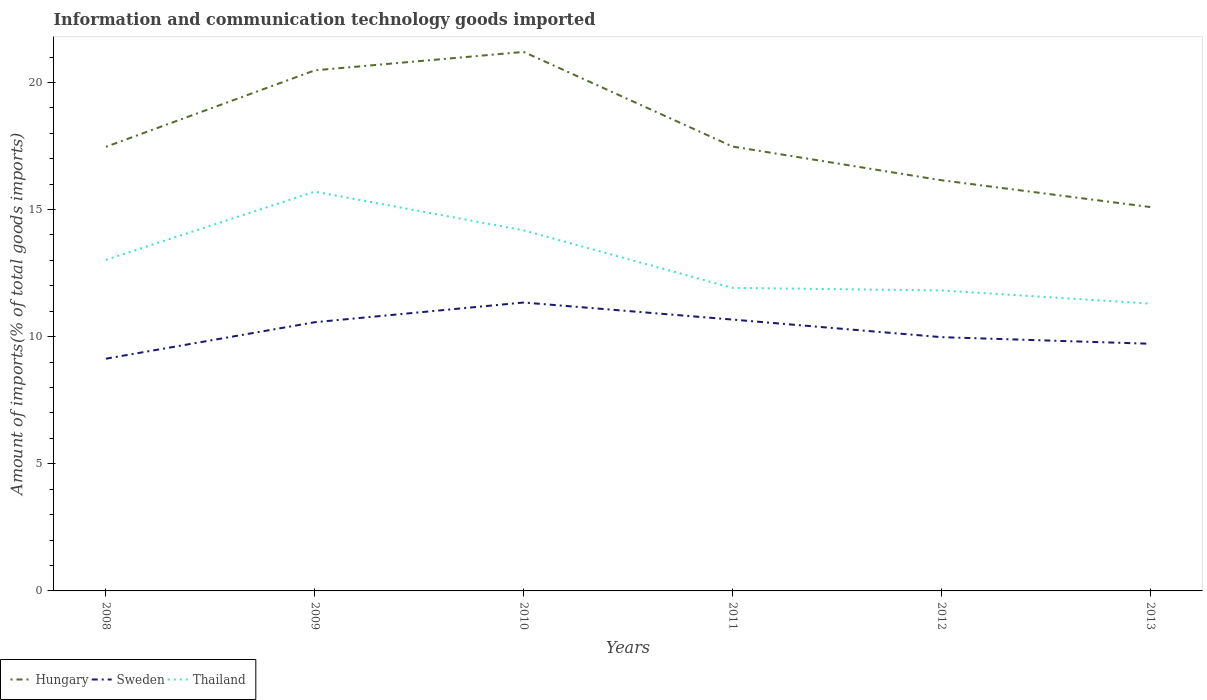Does the line corresponding to Hungary intersect with the line corresponding to Sweden?
Your response must be concise. No. Is the number of lines equal to the number of legend labels?
Provide a succinct answer. Yes. Across all years, what is the maximum amount of goods imported in Sweden?
Provide a short and direct response. 9.13. In which year was the amount of goods imported in Sweden maximum?
Give a very brief answer. 2008. What is the total amount of goods imported in Sweden in the graph?
Ensure brevity in your answer.  -0.59. What is the difference between the highest and the second highest amount of goods imported in Sweden?
Offer a very short reply. 2.21. How many years are there in the graph?
Keep it short and to the point. 6. What is the difference between two consecutive major ticks on the Y-axis?
Keep it short and to the point. 5. Are the values on the major ticks of Y-axis written in scientific E-notation?
Make the answer very short. No. Does the graph contain any zero values?
Provide a short and direct response. No. Does the graph contain grids?
Give a very brief answer. No. How many legend labels are there?
Provide a succinct answer. 3. How are the legend labels stacked?
Offer a very short reply. Horizontal. What is the title of the graph?
Keep it short and to the point. Information and communication technology goods imported. Does "West Bank and Gaza" appear as one of the legend labels in the graph?
Provide a short and direct response. No. What is the label or title of the X-axis?
Offer a very short reply. Years. What is the label or title of the Y-axis?
Offer a very short reply. Amount of imports(% of total goods imports). What is the Amount of imports(% of total goods imports) in Hungary in 2008?
Offer a terse response. 17.47. What is the Amount of imports(% of total goods imports) of Sweden in 2008?
Provide a succinct answer. 9.13. What is the Amount of imports(% of total goods imports) in Thailand in 2008?
Your answer should be compact. 13.02. What is the Amount of imports(% of total goods imports) of Hungary in 2009?
Offer a very short reply. 20.48. What is the Amount of imports(% of total goods imports) in Sweden in 2009?
Offer a very short reply. 10.57. What is the Amount of imports(% of total goods imports) in Thailand in 2009?
Provide a succinct answer. 15.7. What is the Amount of imports(% of total goods imports) of Hungary in 2010?
Ensure brevity in your answer.  21.2. What is the Amount of imports(% of total goods imports) in Sweden in 2010?
Your response must be concise. 11.34. What is the Amount of imports(% of total goods imports) of Thailand in 2010?
Make the answer very short. 14.18. What is the Amount of imports(% of total goods imports) of Hungary in 2011?
Provide a short and direct response. 17.48. What is the Amount of imports(% of total goods imports) in Sweden in 2011?
Your answer should be compact. 10.67. What is the Amount of imports(% of total goods imports) in Thailand in 2011?
Your answer should be very brief. 11.92. What is the Amount of imports(% of total goods imports) in Hungary in 2012?
Your response must be concise. 16.15. What is the Amount of imports(% of total goods imports) in Sweden in 2012?
Offer a terse response. 9.98. What is the Amount of imports(% of total goods imports) of Thailand in 2012?
Provide a succinct answer. 11.82. What is the Amount of imports(% of total goods imports) of Hungary in 2013?
Offer a very short reply. 15.1. What is the Amount of imports(% of total goods imports) in Sweden in 2013?
Your answer should be compact. 9.72. What is the Amount of imports(% of total goods imports) of Thailand in 2013?
Your answer should be compact. 11.3. Across all years, what is the maximum Amount of imports(% of total goods imports) of Hungary?
Ensure brevity in your answer.  21.2. Across all years, what is the maximum Amount of imports(% of total goods imports) in Sweden?
Give a very brief answer. 11.34. Across all years, what is the maximum Amount of imports(% of total goods imports) in Thailand?
Offer a terse response. 15.7. Across all years, what is the minimum Amount of imports(% of total goods imports) in Hungary?
Make the answer very short. 15.1. Across all years, what is the minimum Amount of imports(% of total goods imports) of Sweden?
Ensure brevity in your answer.  9.13. Across all years, what is the minimum Amount of imports(% of total goods imports) of Thailand?
Give a very brief answer. 11.3. What is the total Amount of imports(% of total goods imports) of Hungary in the graph?
Give a very brief answer. 107.87. What is the total Amount of imports(% of total goods imports) of Sweden in the graph?
Your answer should be compact. 61.42. What is the total Amount of imports(% of total goods imports) of Thailand in the graph?
Your response must be concise. 77.95. What is the difference between the Amount of imports(% of total goods imports) in Hungary in 2008 and that in 2009?
Offer a very short reply. -3.01. What is the difference between the Amount of imports(% of total goods imports) in Sweden in 2008 and that in 2009?
Provide a short and direct response. -1.44. What is the difference between the Amount of imports(% of total goods imports) of Thailand in 2008 and that in 2009?
Make the answer very short. -2.68. What is the difference between the Amount of imports(% of total goods imports) of Hungary in 2008 and that in 2010?
Your response must be concise. -3.73. What is the difference between the Amount of imports(% of total goods imports) of Sweden in 2008 and that in 2010?
Your response must be concise. -2.21. What is the difference between the Amount of imports(% of total goods imports) in Thailand in 2008 and that in 2010?
Provide a short and direct response. -1.16. What is the difference between the Amount of imports(% of total goods imports) in Hungary in 2008 and that in 2011?
Give a very brief answer. -0.01. What is the difference between the Amount of imports(% of total goods imports) in Sweden in 2008 and that in 2011?
Provide a short and direct response. -1.54. What is the difference between the Amount of imports(% of total goods imports) of Thailand in 2008 and that in 2011?
Provide a short and direct response. 1.1. What is the difference between the Amount of imports(% of total goods imports) of Hungary in 2008 and that in 2012?
Keep it short and to the point. 1.31. What is the difference between the Amount of imports(% of total goods imports) in Sweden in 2008 and that in 2012?
Provide a succinct answer. -0.85. What is the difference between the Amount of imports(% of total goods imports) in Thailand in 2008 and that in 2012?
Your response must be concise. 1.2. What is the difference between the Amount of imports(% of total goods imports) of Hungary in 2008 and that in 2013?
Ensure brevity in your answer.  2.37. What is the difference between the Amount of imports(% of total goods imports) of Sweden in 2008 and that in 2013?
Your response must be concise. -0.59. What is the difference between the Amount of imports(% of total goods imports) of Thailand in 2008 and that in 2013?
Your answer should be compact. 1.72. What is the difference between the Amount of imports(% of total goods imports) of Hungary in 2009 and that in 2010?
Provide a short and direct response. -0.72. What is the difference between the Amount of imports(% of total goods imports) in Sweden in 2009 and that in 2010?
Keep it short and to the point. -0.78. What is the difference between the Amount of imports(% of total goods imports) in Thailand in 2009 and that in 2010?
Your response must be concise. 1.52. What is the difference between the Amount of imports(% of total goods imports) of Hungary in 2009 and that in 2011?
Make the answer very short. 3. What is the difference between the Amount of imports(% of total goods imports) in Sweden in 2009 and that in 2011?
Offer a terse response. -0.1. What is the difference between the Amount of imports(% of total goods imports) in Thailand in 2009 and that in 2011?
Make the answer very short. 3.79. What is the difference between the Amount of imports(% of total goods imports) of Hungary in 2009 and that in 2012?
Provide a succinct answer. 4.32. What is the difference between the Amount of imports(% of total goods imports) of Sweden in 2009 and that in 2012?
Provide a short and direct response. 0.59. What is the difference between the Amount of imports(% of total goods imports) of Thailand in 2009 and that in 2012?
Offer a very short reply. 3.89. What is the difference between the Amount of imports(% of total goods imports) of Hungary in 2009 and that in 2013?
Your response must be concise. 5.38. What is the difference between the Amount of imports(% of total goods imports) of Sweden in 2009 and that in 2013?
Offer a terse response. 0.85. What is the difference between the Amount of imports(% of total goods imports) in Thailand in 2009 and that in 2013?
Provide a short and direct response. 4.4. What is the difference between the Amount of imports(% of total goods imports) of Hungary in 2010 and that in 2011?
Your answer should be very brief. 3.72. What is the difference between the Amount of imports(% of total goods imports) in Sweden in 2010 and that in 2011?
Your response must be concise. 0.67. What is the difference between the Amount of imports(% of total goods imports) in Thailand in 2010 and that in 2011?
Ensure brevity in your answer.  2.26. What is the difference between the Amount of imports(% of total goods imports) of Hungary in 2010 and that in 2012?
Your response must be concise. 5.05. What is the difference between the Amount of imports(% of total goods imports) in Sweden in 2010 and that in 2012?
Provide a succinct answer. 1.36. What is the difference between the Amount of imports(% of total goods imports) in Thailand in 2010 and that in 2012?
Make the answer very short. 2.36. What is the difference between the Amount of imports(% of total goods imports) of Hungary in 2010 and that in 2013?
Provide a succinct answer. 6.1. What is the difference between the Amount of imports(% of total goods imports) in Sweden in 2010 and that in 2013?
Provide a short and direct response. 1.62. What is the difference between the Amount of imports(% of total goods imports) in Thailand in 2010 and that in 2013?
Offer a very short reply. 2.88. What is the difference between the Amount of imports(% of total goods imports) of Hungary in 2011 and that in 2012?
Give a very brief answer. 1.33. What is the difference between the Amount of imports(% of total goods imports) of Sweden in 2011 and that in 2012?
Make the answer very short. 0.69. What is the difference between the Amount of imports(% of total goods imports) of Thailand in 2011 and that in 2012?
Provide a succinct answer. 0.1. What is the difference between the Amount of imports(% of total goods imports) in Hungary in 2011 and that in 2013?
Your answer should be compact. 2.38. What is the difference between the Amount of imports(% of total goods imports) of Sweden in 2011 and that in 2013?
Make the answer very short. 0.95. What is the difference between the Amount of imports(% of total goods imports) in Thailand in 2011 and that in 2013?
Provide a succinct answer. 0.62. What is the difference between the Amount of imports(% of total goods imports) in Hungary in 2012 and that in 2013?
Make the answer very short. 1.05. What is the difference between the Amount of imports(% of total goods imports) in Sweden in 2012 and that in 2013?
Your response must be concise. 0.26. What is the difference between the Amount of imports(% of total goods imports) of Thailand in 2012 and that in 2013?
Make the answer very short. 0.52. What is the difference between the Amount of imports(% of total goods imports) of Hungary in 2008 and the Amount of imports(% of total goods imports) of Sweden in 2009?
Your answer should be compact. 6.9. What is the difference between the Amount of imports(% of total goods imports) in Hungary in 2008 and the Amount of imports(% of total goods imports) in Thailand in 2009?
Ensure brevity in your answer.  1.76. What is the difference between the Amount of imports(% of total goods imports) in Sweden in 2008 and the Amount of imports(% of total goods imports) in Thailand in 2009?
Offer a very short reply. -6.57. What is the difference between the Amount of imports(% of total goods imports) of Hungary in 2008 and the Amount of imports(% of total goods imports) of Sweden in 2010?
Give a very brief answer. 6.12. What is the difference between the Amount of imports(% of total goods imports) of Hungary in 2008 and the Amount of imports(% of total goods imports) of Thailand in 2010?
Your answer should be very brief. 3.29. What is the difference between the Amount of imports(% of total goods imports) of Sweden in 2008 and the Amount of imports(% of total goods imports) of Thailand in 2010?
Your response must be concise. -5.05. What is the difference between the Amount of imports(% of total goods imports) in Hungary in 2008 and the Amount of imports(% of total goods imports) in Sweden in 2011?
Your answer should be compact. 6.79. What is the difference between the Amount of imports(% of total goods imports) in Hungary in 2008 and the Amount of imports(% of total goods imports) in Thailand in 2011?
Provide a succinct answer. 5.55. What is the difference between the Amount of imports(% of total goods imports) of Sweden in 2008 and the Amount of imports(% of total goods imports) of Thailand in 2011?
Give a very brief answer. -2.79. What is the difference between the Amount of imports(% of total goods imports) in Hungary in 2008 and the Amount of imports(% of total goods imports) in Sweden in 2012?
Keep it short and to the point. 7.49. What is the difference between the Amount of imports(% of total goods imports) of Hungary in 2008 and the Amount of imports(% of total goods imports) of Thailand in 2012?
Ensure brevity in your answer.  5.65. What is the difference between the Amount of imports(% of total goods imports) of Sweden in 2008 and the Amount of imports(% of total goods imports) of Thailand in 2012?
Ensure brevity in your answer.  -2.68. What is the difference between the Amount of imports(% of total goods imports) of Hungary in 2008 and the Amount of imports(% of total goods imports) of Sweden in 2013?
Your answer should be compact. 7.75. What is the difference between the Amount of imports(% of total goods imports) in Hungary in 2008 and the Amount of imports(% of total goods imports) in Thailand in 2013?
Your response must be concise. 6.17. What is the difference between the Amount of imports(% of total goods imports) of Sweden in 2008 and the Amount of imports(% of total goods imports) of Thailand in 2013?
Keep it short and to the point. -2.17. What is the difference between the Amount of imports(% of total goods imports) of Hungary in 2009 and the Amount of imports(% of total goods imports) of Sweden in 2010?
Provide a short and direct response. 9.13. What is the difference between the Amount of imports(% of total goods imports) of Hungary in 2009 and the Amount of imports(% of total goods imports) of Thailand in 2010?
Your answer should be compact. 6.29. What is the difference between the Amount of imports(% of total goods imports) in Sweden in 2009 and the Amount of imports(% of total goods imports) in Thailand in 2010?
Your answer should be very brief. -3.61. What is the difference between the Amount of imports(% of total goods imports) in Hungary in 2009 and the Amount of imports(% of total goods imports) in Sweden in 2011?
Make the answer very short. 9.8. What is the difference between the Amount of imports(% of total goods imports) of Hungary in 2009 and the Amount of imports(% of total goods imports) of Thailand in 2011?
Your answer should be very brief. 8.56. What is the difference between the Amount of imports(% of total goods imports) of Sweden in 2009 and the Amount of imports(% of total goods imports) of Thailand in 2011?
Your response must be concise. -1.35. What is the difference between the Amount of imports(% of total goods imports) of Hungary in 2009 and the Amount of imports(% of total goods imports) of Sweden in 2012?
Ensure brevity in your answer.  10.49. What is the difference between the Amount of imports(% of total goods imports) of Hungary in 2009 and the Amount of imports(% of total goods imports) of Thailand in 2012?
Keep it short and to the point. 8.66. What is the difference between the Amount of imports(% of total goods imports) of Sweden in 2009 and the Amount of imports(% of total goods imports) of Thailand in 2012?
Make the answer very short. -1.25. What is the difference between the Amount of imports(% of total goods imports) in Hungary in 2009 and the Amount of imports(% of total goods imports) in Sweden in 2013?
Ensure brevity in your answer.  10.75. What is the difference between the Amount of imports(% of total goods imports) in Hungary in 2009 and the Amount of imports(% of total goods imports) in Thailand in 2013?
Offer a terse response. 9.17. What is the difference between the Amount of imports(% of total goods imports) of Sweden in 2009 and the Amount of imports(% of total goods imports) of Thailand in 2013?
Offer a very short reply. -0.73. What is the difference between the Amount of imports(% of total goods imports) in Hungary in 2010 and the Amount of imports(% of total goods imports) in Sweden in 2011?
Your answer should be compact. 10.53. What is the difference between the Amount of imports(% of total goods imports) in Hungary in 2010 and the Amount of imports(% of total goods imports) in Thailand in 2011?
Make the answer very short. 9.28. What is the difference between the Amount of imports(% of total goods imports) of Sweden in 2010 and the Amount of imports(% of total goods imports) of Thailand in 2011?
Give a very brief answer. -0.58. What is the difference between the Amount of imports(% of total goods imports) in Hungary in 2010 and the Amount of imports(% of total goods imports) in Sweden in 2012?
Ensure brevity in your answer.  11.22. What is the difference between the Amount of imports(% of total goods imports) of Hungary in 2010 and the Amount of imports(% of total goods imports) of Thailand in 2012?
Provide a short and direct response. 9.38. What is the difference between the Amount of imports(% of total goods imports) in Sweden in 2010 and the Amount of imports(% of total goods imports) in Thailand in 2012?
Your answer should be very brief. -0.47. What is the difference between the Amount of imports(% of total goods imports) in Hungary in 2010 and the Amount of imports(% of total goods imports) in Sweden in 2013?
Offer a very short reply. 11.48. What is the difference between the Amount of imports(% of total goods imports) in Hungary in 2010 and the Amount of imports(% of total goods imports) in Thailand in 2013?
Offer a terse response. 9.9. What is the difference between the Amount of imports(% of total goods imports) in Sweden in 2010 and the Amount of imports(% of total goods imports) in Thailand in 2013?
Ensure brevity in your answer.  0.04. What is the difference between the Amount of imports(% of total goods imports) in Hungary in 2011 and the Amount of imports(% of total goods imports) in Sweden in 2012?
Make the answer very short. 7.5. What is the difference between the Amount of imports(% of total goods imports) in Hungary in 2011 and the Amount of imports(% of total goods imports) in Thailand in 2012?
Ensure brevity in your answer.  5.66. What is the difference between the Amount of imports(% of total goods imports) in Sweden in 2011 and the Amount of imports(% of total goods imports) in Thailand in 2012?
Offer a very short reply. -1.15. What is the difference between the Amount of imports(% of total goods imports) of Hungary in 2011 and the Amount of imports(% of total goods imports) of Sweden in 2013?
Keep it short and to the point. 7.76. What is the difference between the Amount of imports(% of total goods imports) in Hungary in 2011 and the Amount of imports(% of total goods imports) in Thailand in 2013?
Offer a very short reply. 6.18. What is the difference between the Amount of imports(% of total goods imports) of Sweden in 2011 and the Amount of imports(% of total goods imports) of Thailand in 2013?
Give a very brief answer. -0.63. What is the difference between the Amount of imports(% of total goods imports) of Hungary in 2012 and the Amount of imports(% of total goods imports) of Sweden in 2013?
Your response must be concise. 6.43. What is the difference between the Amount of imports(% of total goods imports) in Hungary in 2012 and the Amount of imports(% of total goods imports) in Thailand in 2013?
Keep it short and to the point. 4.85. What is the difference between the Amount of imports(% of total goods imports) of Sweden in 2012 and the Amount of imports(% of total goods imports) of Thailand in 2013?
Offer a very short reply. -1.32. What is the average Amount of imports(% of total goods imports) of Hungary per year?
Make the answer very short. 17.98. What is the average Amount of imports(% of total goods imports) of Sweden per year?
Ensure brevity in your answer.  10.24. What is the average Amount of imports(% of total goods imports) of Thailand per year?
Offer a terse response. 12.99. In the year 2008, what is the difference between the Amount of imports(% of total goods imports) of Hungary and Amount of imports(% of total goods imports) of Sweden?
Provide a succinct answer. 8.33. In the year 2008, what is the difference between the Amount of imports(% of total goods imports) in Hungary and Amount of imports(% of total goods imports) in Thailand?
Ensure brevity in your answer.  4.44. In the year 2008, what is the difference between the Amount of imports(% of total goods imports) in Sweden and Amount of imports(% of total goods imports) in Thailand?
Your answer should be very brief. -3.89. In the year 2009, what is the difference between the Amount of imports(% of total goods imports) of Hungary and Amount of imports(% of total goods imports) of Sweden?
Your response must be concise. 9.91. In the year 2009, what is the difference between the Amount of imports(% of total goods imports) in Hungary and Amount of imports(% of total goods imports) in Thailand?
Your answer should be very brief. 4.77. In the year 2009, what is the difference between the Amount of imports(% of total goods imports) in Sweden and Amount of imports(% of total goods imports) in Thailand?
Provide a short and direct response. -5.14. In the year 2010, what is the difference between the Amount of imports(% of total goods imports) in Hungary and Amount of imports(% of total goods imports) in Sweden?
Your answer should be very brief. 9.86. In the year 2010, what is the difference between the Amount of imports(% of total goods imports) of Hungary and Amount of imports(% of total goods imports) of Thailand?
Offer a very short reply. 7.02. In the year 2010, what is the difference between the Amount of imports(% of total goods imports) of Sweden and Amount of imports(% of total goods imports) of Thailand?
Offer a terse response. -2.84. In the year 2011, what is the difference between the Amount of imports(% of total goods imports) of Hungary and Amount of imports(% of total goods imports) of Sweden?
Provide a succinct answer. 6.81. In the year 2011, what is the difference between the Amount of imports(% of total goods imports) of Hungary and Amount of imports(% of total goods imports) of Thailand?
Your answer should be compact. 5.56. In the year 2011, what is the difference between the Amount of imports(% of total goods imports) in Sweden and Amount of imports(% of total goods imports) in Thailand?
Keep it short and to the point. -1.25. In the year 2012, what is the difference between the Amount of imports(% of total goods imports) of Hungary and Amount of imports(% of total goods imports) of Sweden?
Make the answer very short. 6.17. In the year 2012, what is the difference between the Amount of imports(% of total goods imports) of Hungary and Amount of imports(% of total goods imports) of Thailand?
Offer a very short reply. 4.33. In the year 2012, what is the difference between the Amount of imports(% of total goods imports) in Sweden and Amount of imports(% of total goods imports) in Thailand?
Provide a short and direct response. -1.84. In the year 2013, what is the difference between the Amount of imports(% of total goods imports) in Hungary and Amount of imports(% of total goods imports) in Sweden?
Offer a very short reply. 5.38. In the year 2013, what is the difference between the Amount of imports(% of total goods imports) in Hungary and Amount of imports(% of total goods imports) in Thailand?
Give a very brief answer. 3.8. In the year 2013, what is the difference between the Amount of imports(% of total goods imports) of Sweden and Amount of imports(% of total goods imports) of Thailand?
Offer a very short reply. -1.58. What is the ratio of the Amount of imports(% of total goods imports) of Hungary in 2008 to that in 2009?
Your answer should be compact. 0.85. What is the ratio of the Amount of imports(% of total goods imports) in Sweden in 2008 to that in 2009?
Provide a short and direct response. 0.86. What is the ratio of the Amount of imports(% of total goods imports) in Thailand in 2008 to that in 2009?
Keep it short and to the point. 0.83. What is the ratio of the Amount of imports(% of total goods imports) in Hungary in 2008 to that in 2010?
Make the answer very short. 0.82. What is the ratio of the Amount of imports(% of total goods imports) of Sweden in 2008 to that in 2010?
Give a very brief answer. 0.81. What is the ratio of the Amount of imports(% of total goods imports) in Thailand in 2008 to that in 2010?
Make the answer very short. 0.92. What is the ratio of the Amount of imports(% of total goods imports) in Sweden in 2008 to that in 2011?
Your answer should be compact. 0.86. What is the ratio of the Amount of imports(% of total goods imports) in Thailand in 2008 to that in 2011?
Offer a very short reply. 1.09. What is the ratio of the Amount of imports(% of total goods imports) of Hungary in 2008 to that in 2012?
Offer a terse response. 1.08. What is the ratio of the Amount of imports(% of total goods imports) in Sweden in 2008 to that in 2012?
Your answer should be compact. 0.92. What is the ratio of the Amount of imports(% of total goods imports) of Thailand in 2008 to that in 2012?
Provide a succinct answer. 1.1. What is the ratio of the Amount of imports(% of total goods imports) in Hungary in 2008 to that in 2013?
Provide a short and direct response. 1.16. What is the ratio of the Amount of imports(% of total goods imports) of Sweden in 2008 to that in 2013?
Offer a very short reply. 0.94. What is the ratio of the Amount of imports(% of total goods imports) in Thailand in 2008 to that in 2013?
Make the answer very short. 1.15. What is the ratio of the Amount of imports(% of total goods imports) in Hungary in 2009 to that in 2010?
Keep it short and to the point. 0.97. What is the ratio of the Amount of imports(% of total goods imports) of Sweden in 2009 to that in 2010?
Provide a short and direct response. 0.93. What is the ratio of the Amount of imports(% of total goods imports) in Thailand in 2009 to that in 2010?
Keep it short and to the point. 1.11. What is the ratio of the Amount of imports(% of total goods imports) of Hungary in 2009 to that in 2011?
Offer a terse response. 1.17. What is the ratio of the Amount of imports(% of total goods imports) in Sweden in 2009 to that in 2011?
Your response must be concise. 0.99. What is the ratio of the Amount of imports(% of total goods imports) of Thailand in 2009 to that in 2011?
Make the answer very short. 1.32. What is the ratio of the Amount of imports(% of total goods imports) of Hungary in 2009 to that in 2012?
Ensure brevity in your answer.  1.27. What is the ratio of the Amount of imports(% of total goods imports) in Sweden in 2009 to that in 2012?
Offer a very short reply. 1.06. What is the ratio of the Amount of imports(% of total goods imports) in Thailand in 2009 to that in 2012?
Make the answer very short. 1.33. What is the ratio of the Amount of imports(% of total goods imports) of Hungary in 2009 to that in 2013?
Your answer should be compact. 1.36. What is the ratio of the Amount of imports(% of total goods imports) of Sweden in 2009 to that in 2013?
Provide a succinct answer. 1.09. What is the ratio of the Amount of imports(% of total goods imports) of Thailand in 2009 to that in 2013?
Offer a terse response. 1.39. What is the ratio of the Amount of imports(% of total goods imports) in Hungary in 2010 to that in 2011?
Your answer should be compact. 1.21. What is the ratio of the Amount of imports(% of total goods imports) in Sweden in 2010 to that in 2011?
Offer a terse response. 1.06. What is the ratio of the Amount of imports(% of total goods imports) in Thailand in 2010 to that in 2011?
Your answer should be compact. 1.19. What is the ratio of the Amount of imports(% of total goods imports) in Hungary in 2010 to that in 2012?
Offer a very short reply. 1.31. What is the ratio of the Amount of imports(% of total goods imports) of Sweden in 2010 to that in 2012?
Keep it short and to the point. 1.14. What is the ratio of the Amount of imports(% of total goods imports) of Thailand in 2010 to that in 2012?
Your answer should be very brief. 1.2. What is the ratio of the Amount of imports(% of total goods imports) in Hungary in 2010 to that in 2013?
Your response must be concise. 1.4. What is the ratio of the Amount of imports(% of total goods imports) in Sweden in 2010 to that in 2013?
Your answer should be compact. 1.17. What is the ratio of the Amount of imports(% of total goods imports) in Thailand in 2010 to that in 2013?
Give a very brief answer. 1.25. What is the ratio of the Amount of imports(% of total goods imports) in Hungary in 2011 to that in 2012?
Your answer should be compact. 1.08. What is the ratio of the Amount of imports(% of total goods imports) in Sweden in 2011 to that in 2012?
Make the answer very short. 1.07. What is the ratio of the Amount of imports(% of total goods imports) in Thailand in 2011 to that in 2012?
Ensure brevity in your answer.  1.01. What is the ratio of the Amount of imports(% of total goods imports) of Hungary in 2011 to that in 2013?
Your answer should be compact. 1.16. What is the ratio of the Amount of imports(% of total goods imports) of Sweden in 2011 to that in 2013?
Make the answer very short. 1.1. What is the ratio of the Amount of imports(% of total goods imports) of Thailand in 2011 to that in 2013?
Provide a short and direct response. 1.05. What is the ratio of the Amount of imports(% of total goods imports) in Hungary in 2012 to that in 2013?
Offer a terse response. 1.07. What is the ratio of the Amount of imports(% of total goods imports) in Sweden in 2012 to that in 2013?
Provide a succinct answer. 1.03. What is the ratio of the Amount of imports(% of total goods imports) of Thailand in 2012 to that in 2013?
Give a very brief answer. 1.05. What is the difference between the highest and the second highest Amount of imports(% of total goods imports) in Hungary?
Make the answer very short. 0.72. What is the difference between the highest and the second highest Amount of imports(% of total goods imports) of Sweden?
Give a very brief answer. 0.67. What is the difference between the highest and the second highest Amount of imports(% of total goods imports) in Thailand?
Offer a terse response. 1.52. What is the difference between the highest and the lowest Amount of imports(% of total goods imports) in Hungary?
Keep it short and to the point. 6.1. What is the difference between the highest and the lowest Amount of imports(% of total goods imports) in Sweden?
Your answer should be compact. 2.21. What is the difference between the highest and the lowest Amount of imports(% of total goods imports) of Thailand?
Provide a short and direct response. 4.4. 